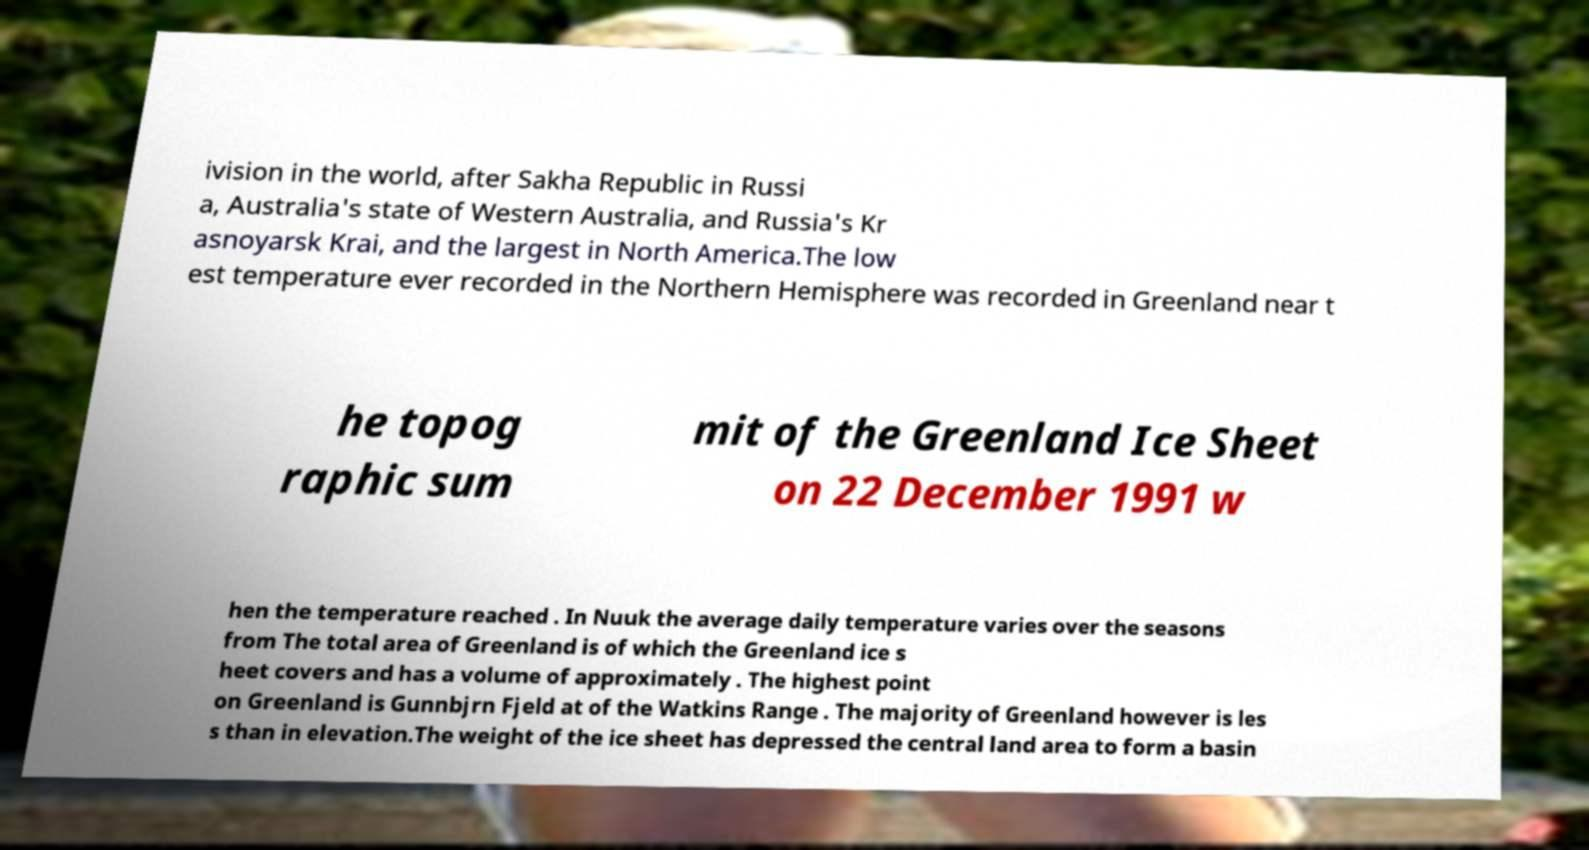Can you read and provide the text displayed in the image?This photo seems to have some interesting text. Can you extract and type it out for me? ivision in the world, after Sakha Republic in Russi a, Australia's state of Western Australia, and Russia's Kr asnoyarsk Krai, and the largest in North America.The low est temperature ever recorded in the Northern Hemisphere was recorded in Greenland near t he topog raphic sum mit of the Greenland Ice Sheet on 22 December 1991 w hen the temperature reached . In Nuuk the average daily temperature varies over the seasons from The total area of Greenland is of which the Greenland ice s heet covers and has a volume of approximately . The highest point on Greenland is Gunnbjrn Fjeld at of the Watkins Range . The majority of Greenland however is les s than in elevation.The weight of the ice sheet has depressed the central land area to form a basin 